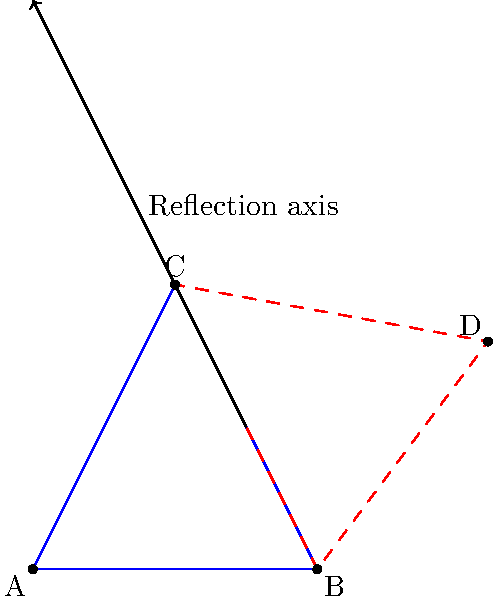In designing a symmetrical snowflake pattern for ski apparel, you want to reflect triangle ABC across line BC to create a full snowflake design. What are the coordinates of point D, which is the reflection of point A across line BC? To find the coordinates of point D, we need to reflect point A across line BC. Here's how we can do this step-by-step:

1. Identify the coordinates:
   A(0,0), B(2,0), C(1,2)

2. The reflection of a point (x,y) across a line can be found using the following formulas:
   $$x' = \frac{(x-x_1)(x_2-x_1) + (y-y_1)(y_2-y_1)}{(x_2-x_1)^2 + (y_2-y_1)^2} (x_2-x_1) - (y-y_1) \frac{y_2-y_1}{x_2-x_1} + x_1$$
   $$y' = \frac{(x-x_1)(x_2-x_1) + (y-y_1)(y_2-y_1)}{(x_2-x_1)^2 + (y_2-y_1)^2} (y_2-y_1) + (x-x_1) \frac{y_2-y_1}{x_2-x_1} + y_1$$

   Where (x_1,y_1) and (x_2,y_2) are the endpoints of the line of reflection.

3. Substitute the values:
   (x,y) = (0,0) (point A)
   (x_1,y_1) = (2,0) (point B)
   (x_2,y_2) = (1,2) (point C)

4. Calculate:
   $$x' = \frac{(0-2)(-1) + (0-0)(2)}{(-1)^2 + (2)^2} (-1) - (0-0) \frac{2}{-1} + 2 = 2$$
   $$y' = \frac{(0-2)(-1) + (0-0)(2)}{(-1)^2 + (2)^2} (2) + (0-2) \frac{2}{-1} + 0 = 4$$

5. Therefore, the coordinates of point D are (2,4).
Answer: (2,4) 